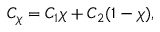Convert formula to latex. <formula><loc_0><loc_0><loc_500><loc_500>C _ { \chi } = C _ { 1 } \chi + C _ { 2 } ( 1 - \chi ) ,</formula> 